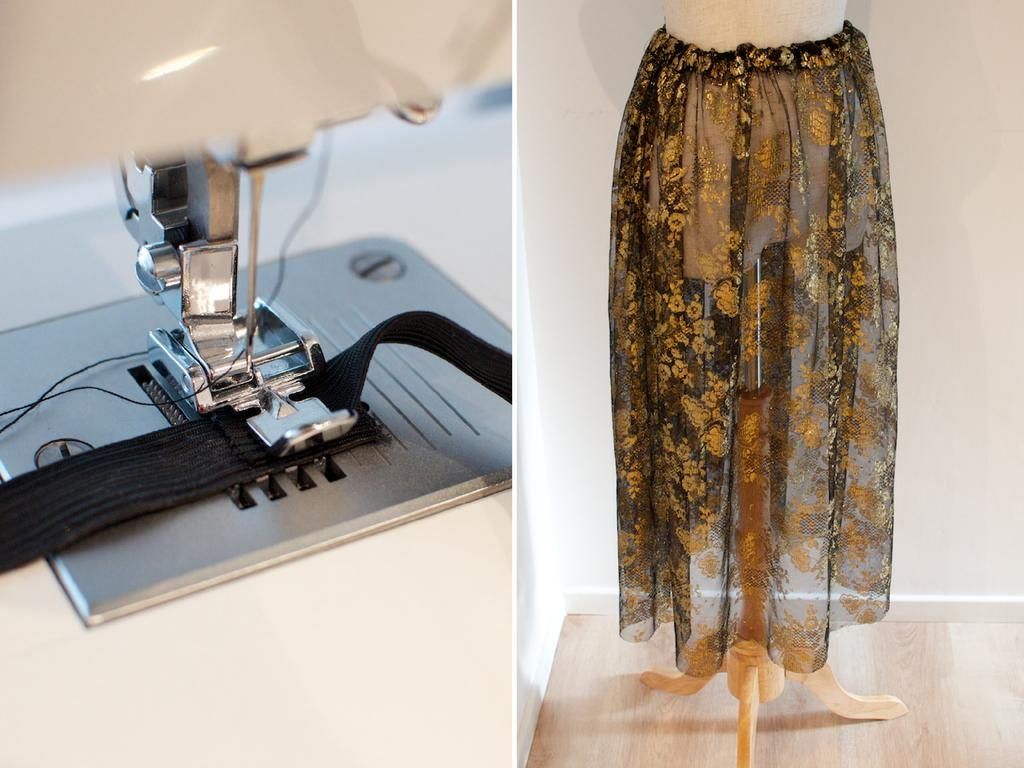What type of artwork is depicted in the image? The image contains a collage of pictures. Can you describe the first picture in the collage? The first picture in the collage shows a sewing machine. What is featured in the second picture of the collage? The second picture in the collage shows a cloth on a stand. What type of secretary can be seen working in the image? There is no secretary present in the image; it contains a collage of pictures featuring a sewing machine and a cloth on a stand. Can you tell me how many boots are visible in the image? There are no boots present in the image. 